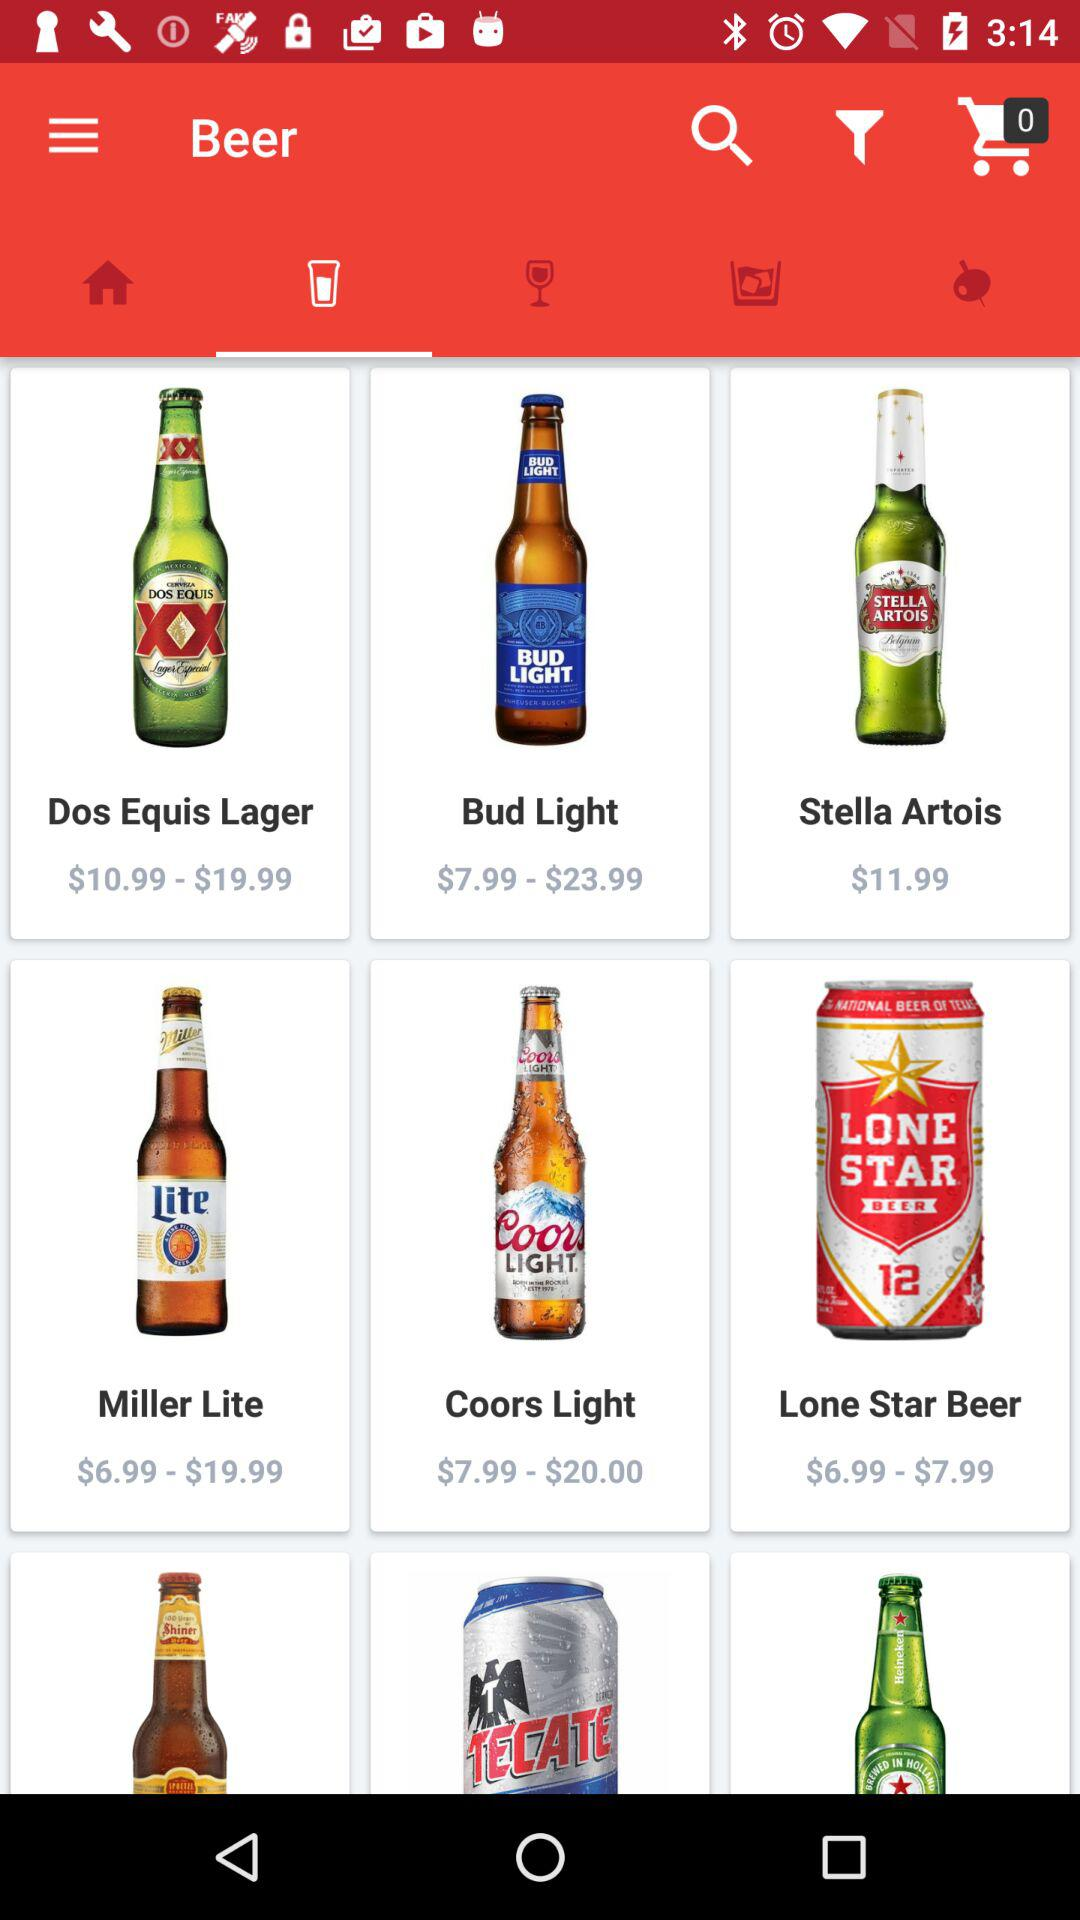What is the price of "Lone Star Beer"? The price ranges from $6.99 to $7.99. 